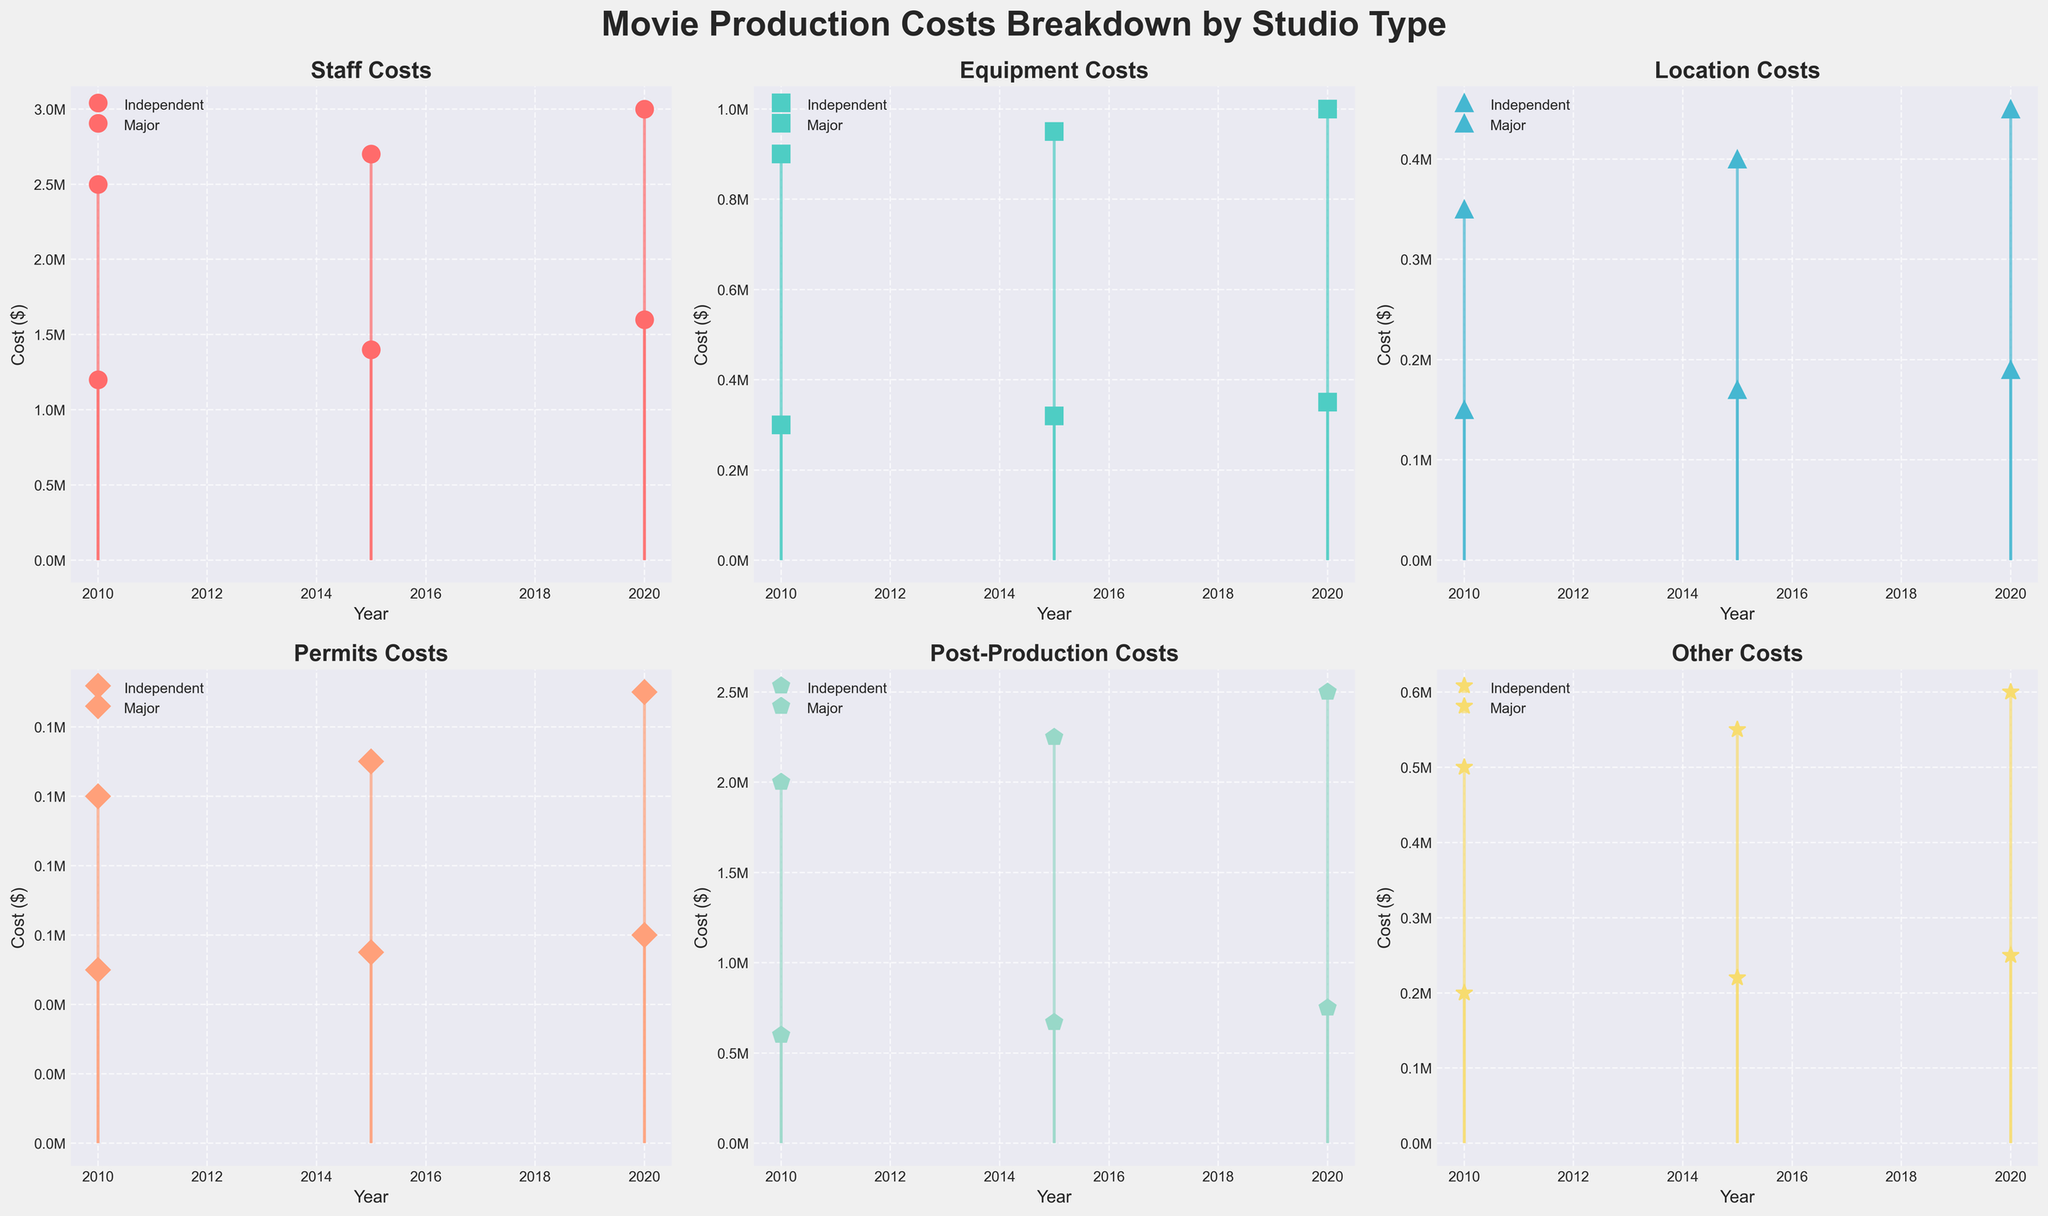What's the title of the plot? The title of the plot is displayed at the top center of the figure. It reads "Movie Production Costs Breakdown by Studio Type".
Answer: Movie Production Costs Breakdown by Studio Type Which cost type had the highest cost for Major studios in 2020? The subplot for each cost type shows the year and corresponding costs. For Major studios in 2020, the "Post-Production Costs" bar reaches the highest, indicating it has the highest cost.
Answer: Post-Production Costs How did the staff costs for Independent studios change from 2010 to 2020? By looking at the subplots for "Staff Costs", the markers and lines for Independent studios show an increase from 1,200,000 in 2010 to 1,600,000 in 2020.
Answer: Increased by 400,000 What is the sum of Location Costs for Major studios across all years? Locate the "Location Costs" subplot and sum up the values for Major studios: 350,000 (2010) + 400,000 (2015) + 450,000 (2020) = 1,200,000.
Answer: 1,200,000 Which studio type had higher equipment costs in 2015, and by how much? In the "Equipment Costs" subplot, compare the values for 2015. Independent: 320,000, Major: 950,000. The difference is 950,000 - 320,000 = 630,000, with Major being higher.
Answer: Major, by 630,000 Did Permit Costs for Independent studios increase or decrease over the given years? Looking at the "Permits Costs" subplot, Independent studios had Permit Costs of 50,000 in 2010, 55,000 in 2015, and 60,000 in 2020. This shows a steady increase.
Answer: Increase How do the trends in post-production costs compare between Independent and Major studios? Examine the "Post-Production Costs" subplot. For Independent studios, the trend is an increase from 600,000 (2010) to 750,000 (2020). For Major studios, the trend is also an increase from 2,000,000 (2010) to 2,500,000 (2020). Both trends show growth.
Answer: Both increasing Between Independent and Major studios, which saw a smaller increase in "Other Costs" from 2010 to 2020? Compare "Other Costs" for both studio types from 2010 to 2020. Independent: from 200,000 to 250,000 (increase of 50,000). Major: from 500,000 to 600,000 (increase of 100,000). Independent studios saw a smaller increase.
Answer: Independent Are there any cost types where the costs for Independent studios decrease over time? Reviewing each cost type's subplot, we see that none of the cost types for Independent studios show a decrease; they all either increase or remain roughly the same over time.
Answer: No 